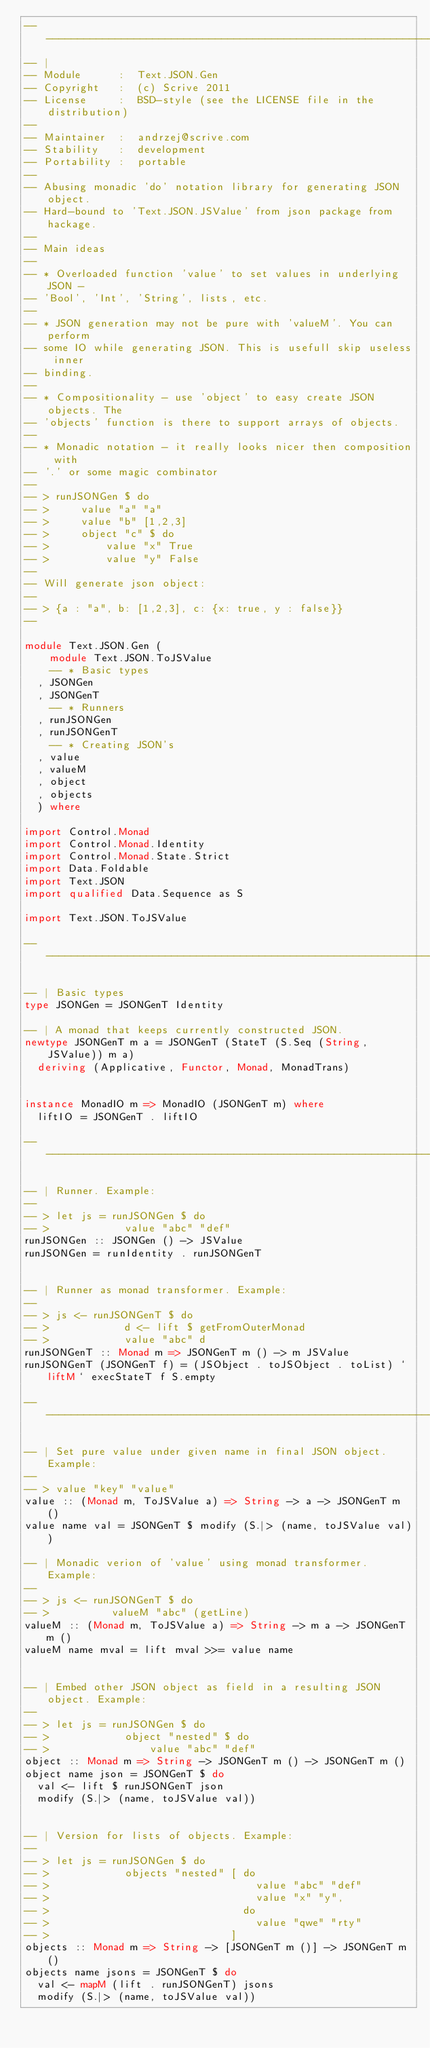Convert code to text. <code><loc_0><loc_0><loc_500><loc_500><_Haskell_>-----------------------------------------------------------------------------
-- |
-- Module      :  Text.JSON.Gen
-- Copyright   :  (c) Scrive 2011
-- License     :  BSD-style (see the LICENSE file in the distribution)
--
-- Maintainer  :  andrzej@scrive.com
-- Stability   :  development
-- Portability :  portable
--
-- Abusing monadic 'do' notation library for generating JSON object.
-- Hard-bound to 'Text.JSON.JSValue' from json package from hackage.
--
-- Main ideas
--
-- * Overloaded function 'value' to set values in underlying JSON -
-- 'Bool', 'Int', 'String', lists, etc.
--
-- * JSON generation may not be pure with 'valueM'. You can perform
-- some IO while generating JSON. This is usefull skip useless inner
-- binding.
--
-- * Compositionality - use 'object' to easy create JSON objects. The
-- 'objects' function is there to support arrays of objects.
--
-- * Monadic notation - it really looks nicer then composition with
-- '.' or some magic combinator
--
-- > runJSONGen $ do
-- >     value "a" "a"
-- >     value "b" [1,2,3]
-- >     object "c" $ do
-- >         value "x" True
-- >         value "y" False
--
-- Will generate json object:
--
-- > {a : "a", b: [1,2,3], c: {x: true, y : false}}
--

module Text.JSON.Gen (
    module Text.JSON.ToJSValue
    -- * Basic types
  , JSONGen
  , JSONGenT
    -- * Runners
  , runJSONGen
  , runJSONGenT
    -- * Creating JSON's
  , value
  , valueM
  , object
  , objects
  ) where

import Control.Monad
import Control.Monad.Identity
import Control.Monad.State.Strict
import Data.Foldable
import Text.JSON
import qualified Data.Sequence as S

import Text.JSON.ToJSValue

-- --------------------------------------------------------------

-- | Basic types
type JSONGen = JSONGenT Identity

-- | A monad that keeps currently constructed JSON.
newtype JSONGenT m a = JSONGenT (StateT (S.Seq (String, JSValue)) m a)
  deriving (Applicative, Functor, Monad, MonadTrans)


instance MonadIO m => MonadIO (JSONGenT m) where
  liftIO = JSONGenT . liftIO

-- --------------------------------------------------------------

-- | Runner. Example:
--
-- > let js = runJSONGen $ do
-- >            value "abc" "def"
runJSONGen :: JSONGen () -> JSValue
runJSONGen = runIdentity . runJSONGenT


-- | Runner as monad transformer. Example:
--
-- > js <- runJSONGenT $ do
-- >            d <- lift $ getFromOuterMonad
-- >            value "abc" d
runJSONGenT :: Monad m => JSONGenT m () -> m JSValue
runJSONGenT (JSONGenT f) = (JSObject . toJSObject . toList) `liftM` execStateT f S.empty

-- --------------------------------------------------------------

-- | Set pure value under given name in final JSON object. Example:
--
-- > value "key" "value"
value :: (Monad m, ToJSValue a) => String -> a -> JSONGenT m ()
value name val = JSONGenT $ modify (S.|> (name, toJSValue val))

-- | Monadic verion of 'value' using monad transformer. Example:
--
-- > js <- runJSONGenT $ do
-- >          valueM "abc" (getLine)
valueM :: (Monad m, ToJSValue a) => String -> m a -> JSONGenT m ()
valueM name mval = lift mval >>= value name


-- | Embed other JSON object as field in a resulting JSON object. Example:
--
-- > let js = runJSONGen $ do
-- >            object "nested" $ do
-- >                value "abc" "def"
object :: Monad m => String -> JSONGenT m () -> JSONGenT m ()
object name json = JSONGenT $ do
  val <- lift $ runJSONGenT json
  modify (S.|> (name, toJSValue val))


-- | Version for lists of objects. Example:
--
-- > let js = runJSONGen $ do
-- >            objects "nested" [ do
-- >                                 value "abc" "def"
-- >                                 value "x" "y",
-- >                               do
-- >                                 value "qwe" "rty"
-- >                             ]
objects :: Monad m => String -> [JSONGenT m ()] -> JSONGenT m ()
objects name jsons = JSONGenT $ do
  val <- mapM (lift . runJSONGenT) jsons
  modify (S.|> (name, toJSValue val))
</code> 